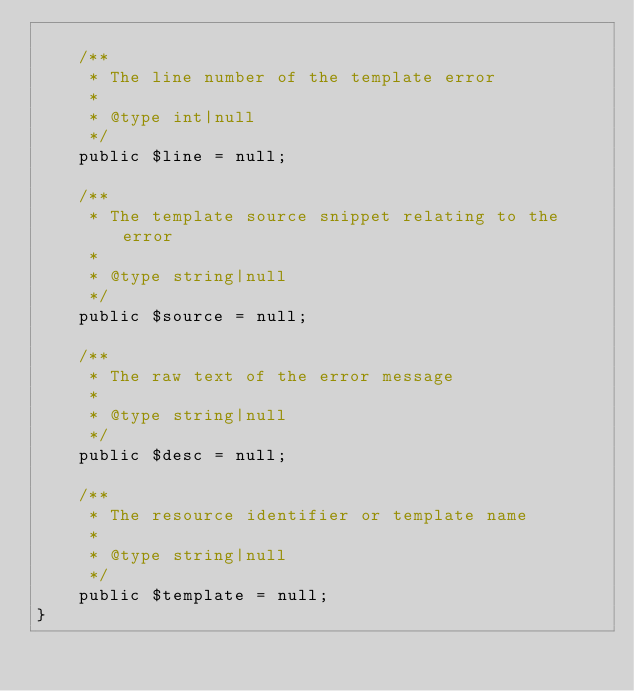<code> <loc_0><loc_0><loc_500><loc_500><_PHP_>
    /**
     * The line number of the template error
     *
     * @type int|null
     */
    public $line = null;

    /**
     * The template source snippet relating to the error
     *
     * @type string|null
     */
    public $source = null;

    /**
     * The raw text of the error message
     *
     * @type string|null
     */
    public $desc = null;

    /**
     * The resource identifier or template name
     *
     * @type string|null
     */
    public $template = null;
}
</code> 